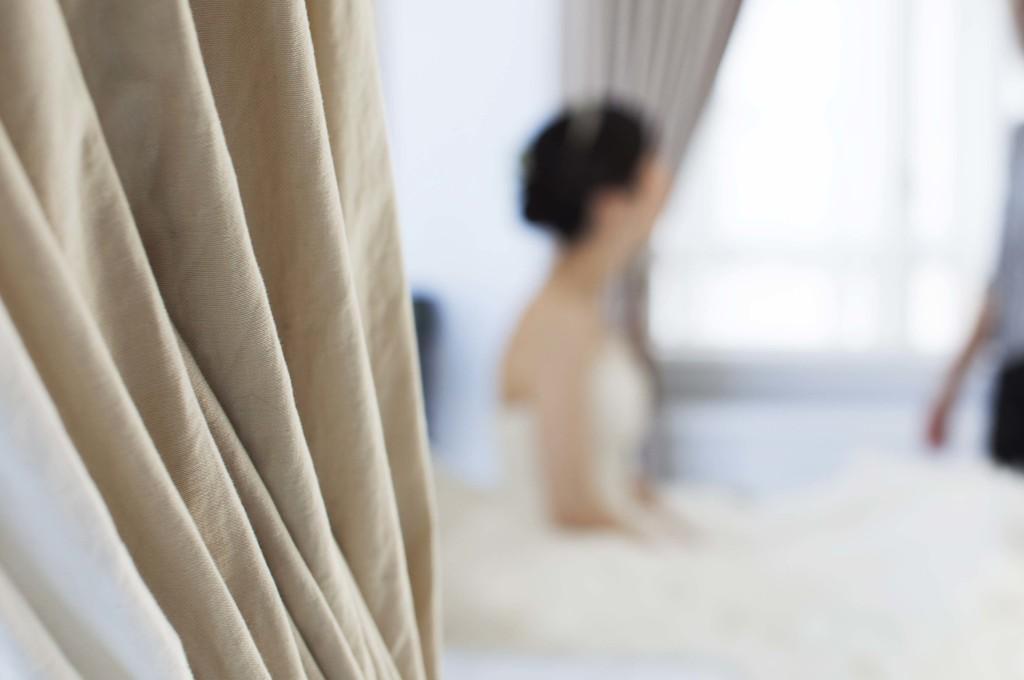Can you describe this image briefly? In this picture, on the left side of the image there is a curtain. At the back there is a woman with white dress is sitting and there is a person standing and there is a window and there is a curtain. 